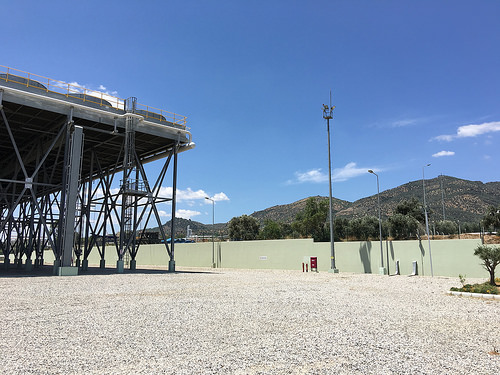<image>
Is the structure on the mountain? No. The structure is not positioned on the mountain. They may be near each other, but the structure is not supported by or resting on top of the mountain. 